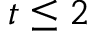<formula> <loc_0><loc_0><loc_500><loc_500>t \leq 2</formula> 